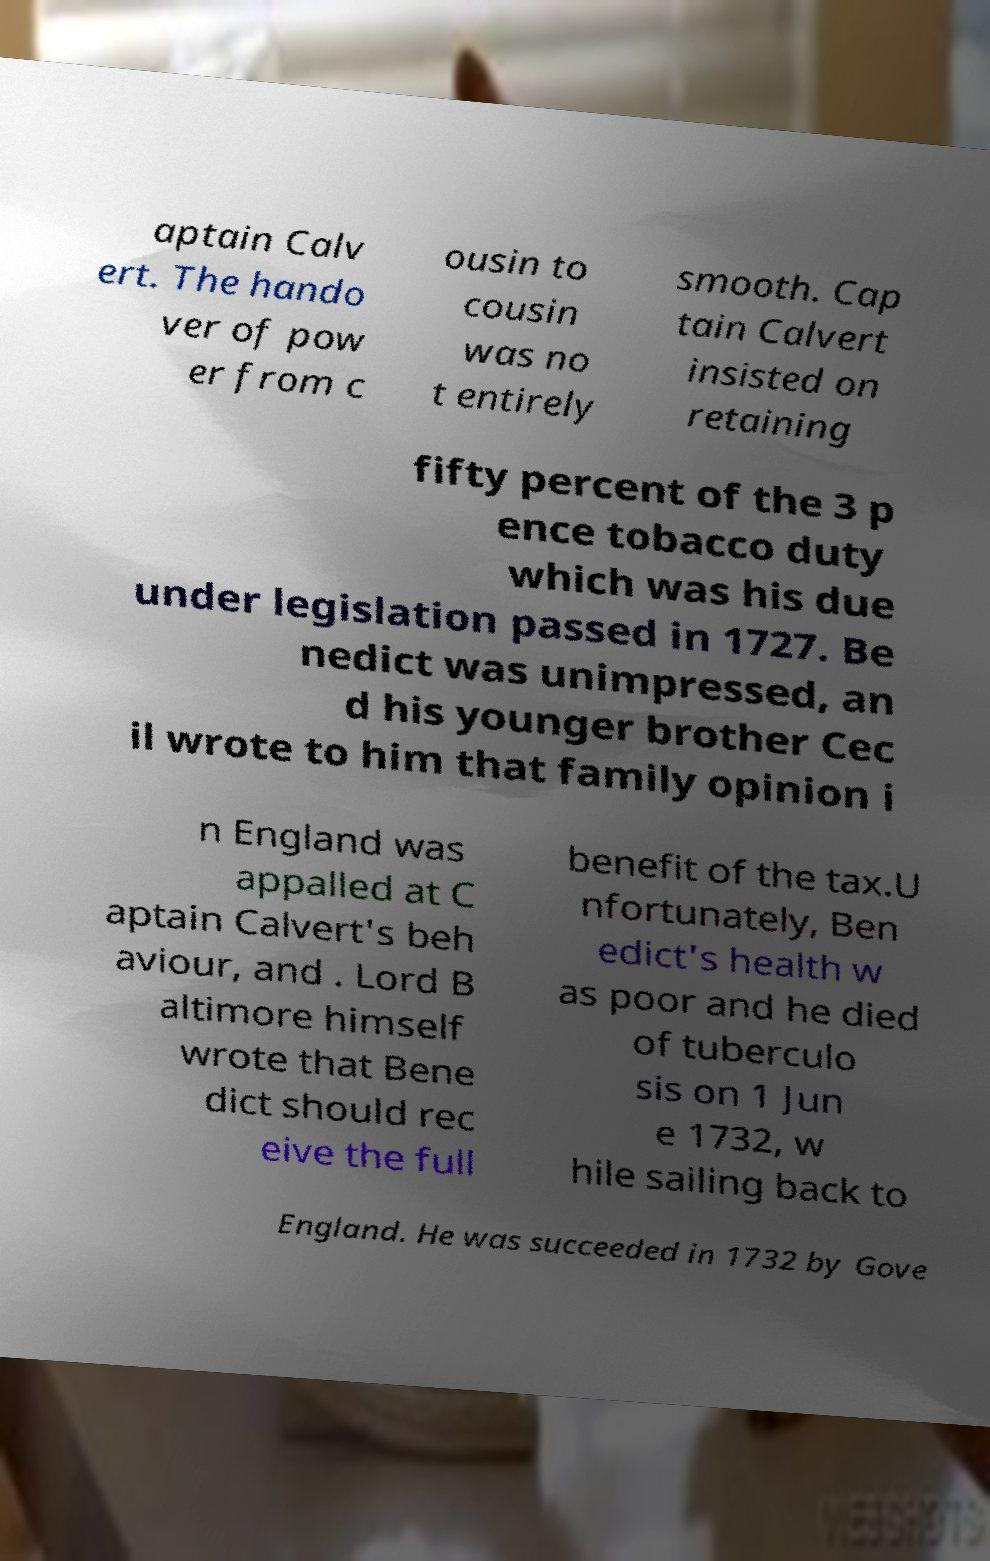Can you accurately transcribe the text from the provided image for me? aptain Calv ert. The hando ver of pow er from c ousin to cousin was no t entirely smooth. Cap tain Calvert insisted on retaining fifty percent of the 3 p ence tobacco duty which was his due under legislation passed in 1727. Be nedict was unimpressed, an d his younger brother Cec il wrote to him that family opinion i n England was appalled at C aptain Calvert's beh aviour, and . Lord B altimore himself wrote that Bene dict should rec eive the full benefit of the tax.U nfortunately, Ben edict's health w as poor and he died of tuberculo sis on 1 Jun e 1732, w hile sailing back to England. He was succeeded in 1732 by Gove 